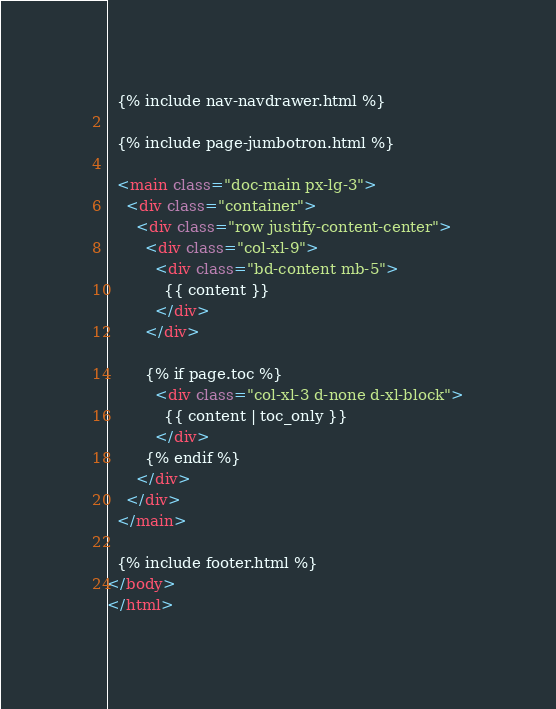Convert code to text. <code><loc_0><loc_0><loc_500><loc_500><_HTML_>
  {% include nav-navdrawer.html %}

  {% include page-jumbotron.html %}

  <main class="doc-main px-lg-3">
    <div class="container">
      <div class="row justify-content-center">
        <div class="col-xl-9">
          <div class="bd-content mb-5">
            {{ content }}
          </div>
        </div>

        {% if page.toc %}
          <div class="col-xl-3 d-none d-xl-block">
            {{ content | toc_only }}
          </div>
        {% endif %}
      </div>
    </div>
  </main>

  {% include footer.html %}
</body>
</html>
</code> 